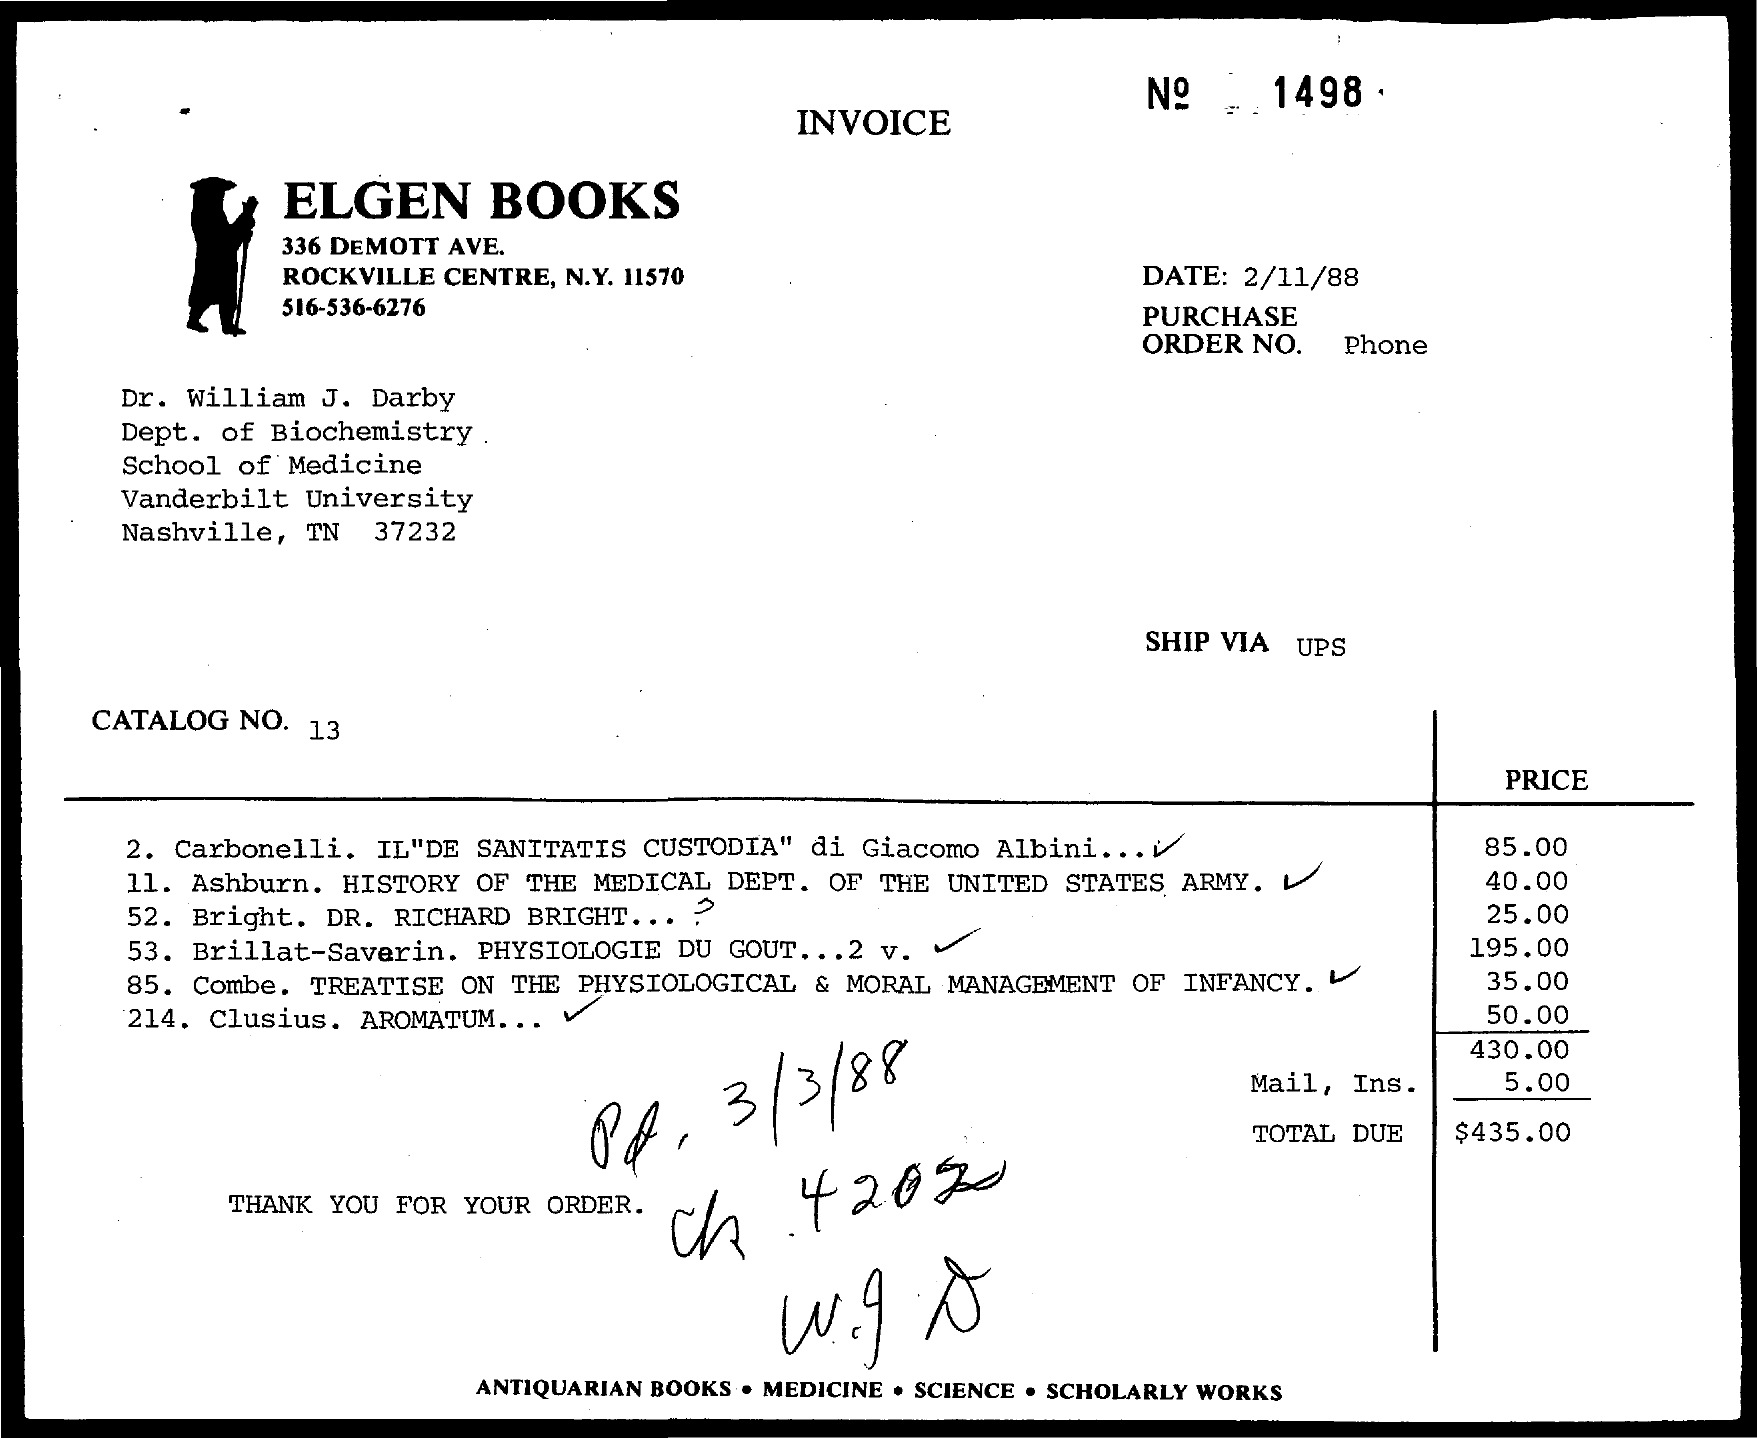What is the name of the book store mentioned in the given invoice?
Your answer should be very brief. Elgen Books. Dr. William J. Darby belongs from which university?
Ensure brevity in your answer.  Vanderbilt university. 